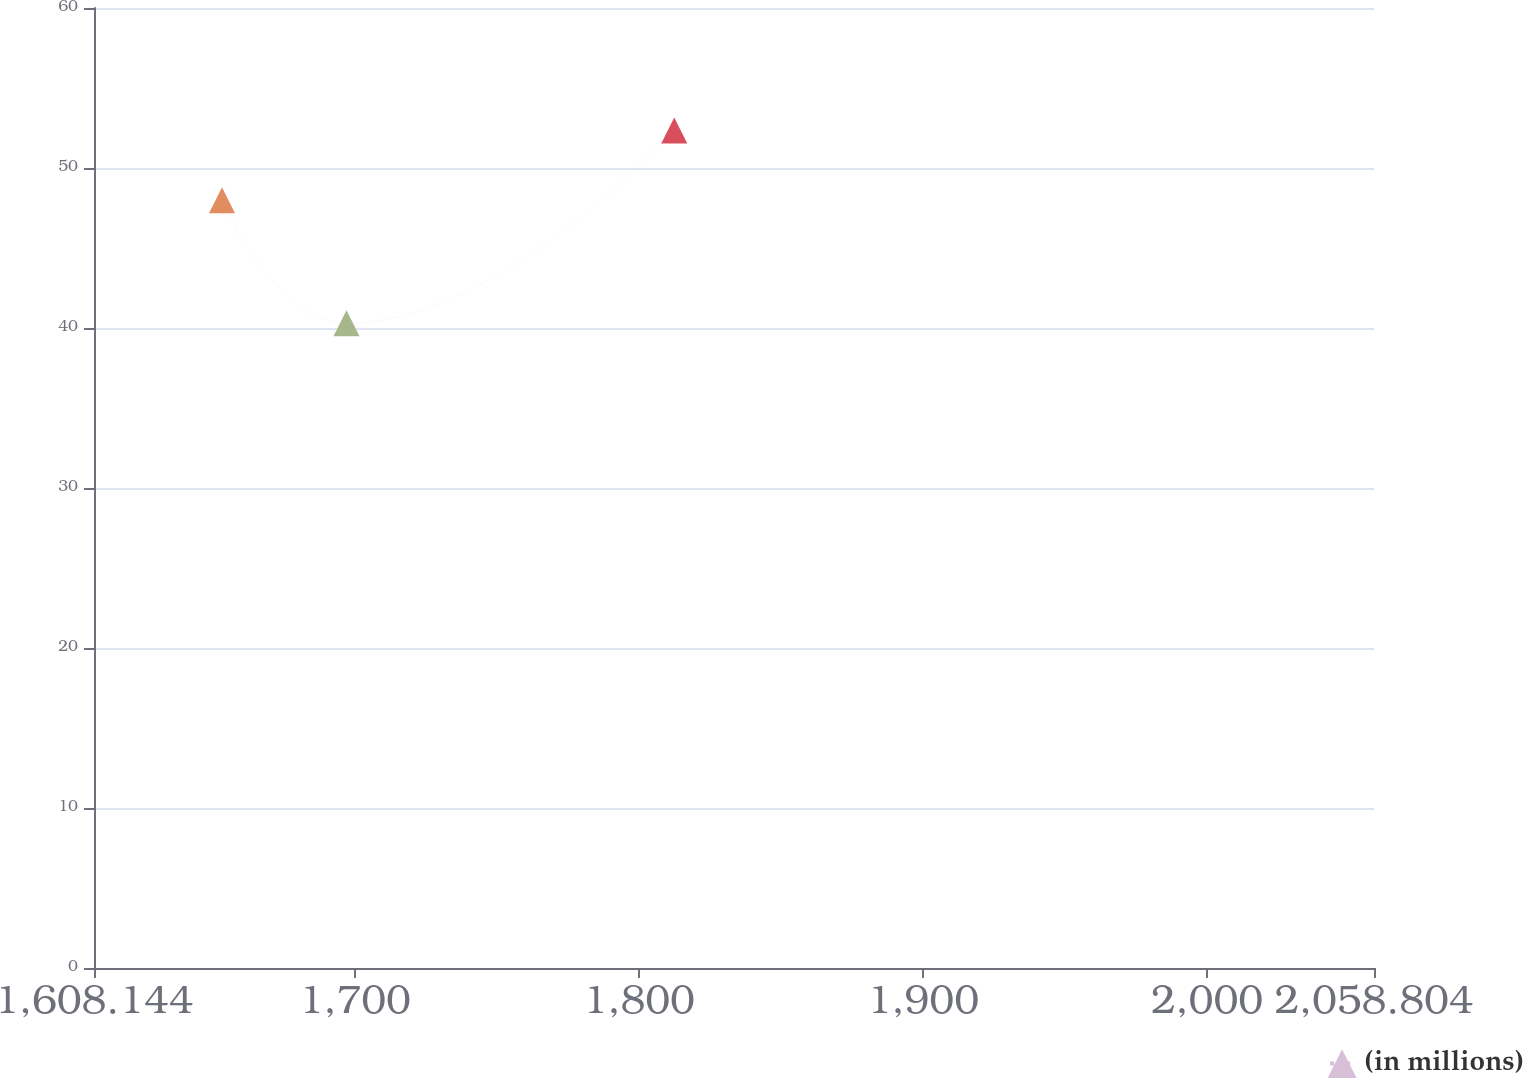Convert chart to OTSL. <chart><loc_0><loc_0><loc_500><loc_500><line_chart><ecel><fcel>(in millions)<nl><fcel>1653.21<fcel>47.99<nl><fcel>1697.04<fcel>40.3<nl><fcel>1812.43<fcel>52.35<nl><fcel>2060.04<fcel>37.32<nl><fcel>2103.87<fcel>35.65<nl></chart> 